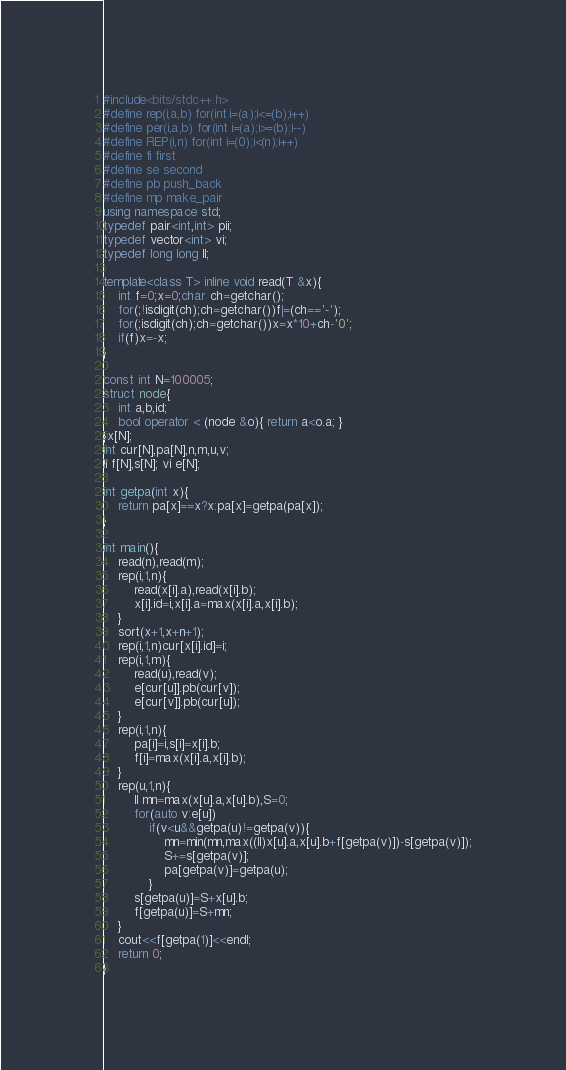Convert code to text. <code><loc_0><loc_0><loc_500><loc_500><_C++_>#include<bits/stdc++.h>
#define rep(i,a,b) for(int i=(a);i<=(b);i++)
#define per(i,a,b) for(int i=(a);i>=(b);i--)
#define REP(i,n) for(int i=(0);i<(n);i++)
#define fi first
#define se second
#define pb push_back
#define mp make_pair
using namespace std;
typedef pair<int,int> pii;
typedef vector<int> vi;
typedef long long ll;
 
template<class T> inline void read(T &x){
	int f=0;x=0;char ch=getchar();
	for(;!isdigit(ch);ch=getchar())f|=(ch=='-');
	for(;isdigit(ch);ch=getchar())x=x*10+ch-'0';
	if(f)x=-x;
}

const int N=100005;
struct node{
	int a,b,id;
	bool operator < (node &o){ return a<o.a; }
}x[N];
int cur[N],pa[N],n,m,u,v;
ll f[N],s[N]; vi e[N];

int getpa(int x){
	return pa[x]==x?x:pa[x]=getpa(pa[x]);
}

int main(){
	read(n),read(m);
	rep(i,1,n){
		read(x[i].a),read(x[i].b);
		x[i].id=i,x[i].a=max(x[i].a,x[i].b);
	}
	sort(x+1,x+n+1);
	rep(i,1,n)cur[x[i].id]=i;
	rep(i,1,m){
		read(u),read(v);
		e[cur[u]].pb(cur[v]);
		e[cur[v]].pb(cur[u]);
	}
	rep(i,1,n){
		pa[i]=i,s[i]=x[i].b;
		f[i]=max(x[i].a,x[i].b);
	}
	rep(u,1,n){
		ll mn=max(x[u].a,x[u].b),S=0;
		for(auto v:e[u])
			if(v<u&&getpa(u)!=getpa(v)){
				mn=min(mn,max((ll)x[u].a,x[u].b+f[getpa(v)])-s[getpa(v)]);
				S+=s[getpa(v)];
				pa[getpa(v)]=getpa(u);
			}
		s[getpa(u)]=S+x[u].b;
		f[getpa(u)]=S+mn;
	}
	cout<<f[getpa(1)]<<endl;
	return 0;
}</code> 